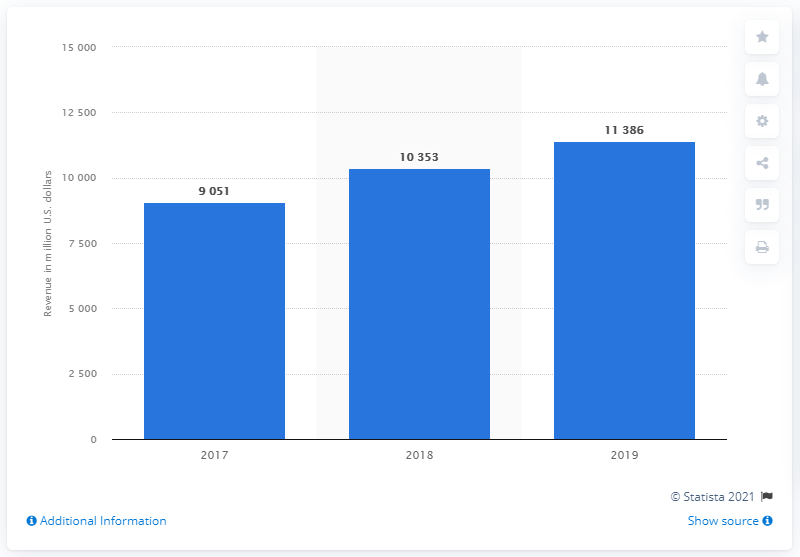Highlight a few significant elements in this photo. Microsoft's gaming revenue from July 2018 to June 2019 totaled 113,860 million USD. 